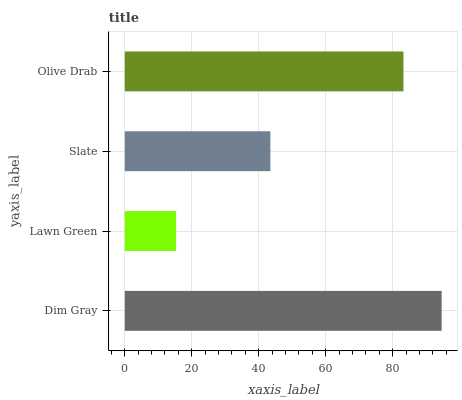Is Lawn Green the minimum?
Answer yes or no. Yes. Is Dim Gray the maximum?
Answer yes or no. Yes. Is Slate the minimum?
Answer yes or no. No. Is Slate the maximum?
Answer yes or no. No. Is Slate greater than Lawn Green?
Answer yes or no. Yes. Is Lawn Green less than Slate?
Answer yes or no. Yes. Is Lawn Green greater than Slate?
Answer yes or no. No. Is Slate less than Lawn Green?
Answer yes or no. No. Is Olive Drab the high median?
Answer yes or no. Yes. Is Slate the low median?
Answer yes or no. Yes. Is Slate the high median?
Answer yes or no. No. Is Olive Drab the low median?
Answer yes or no. No. 